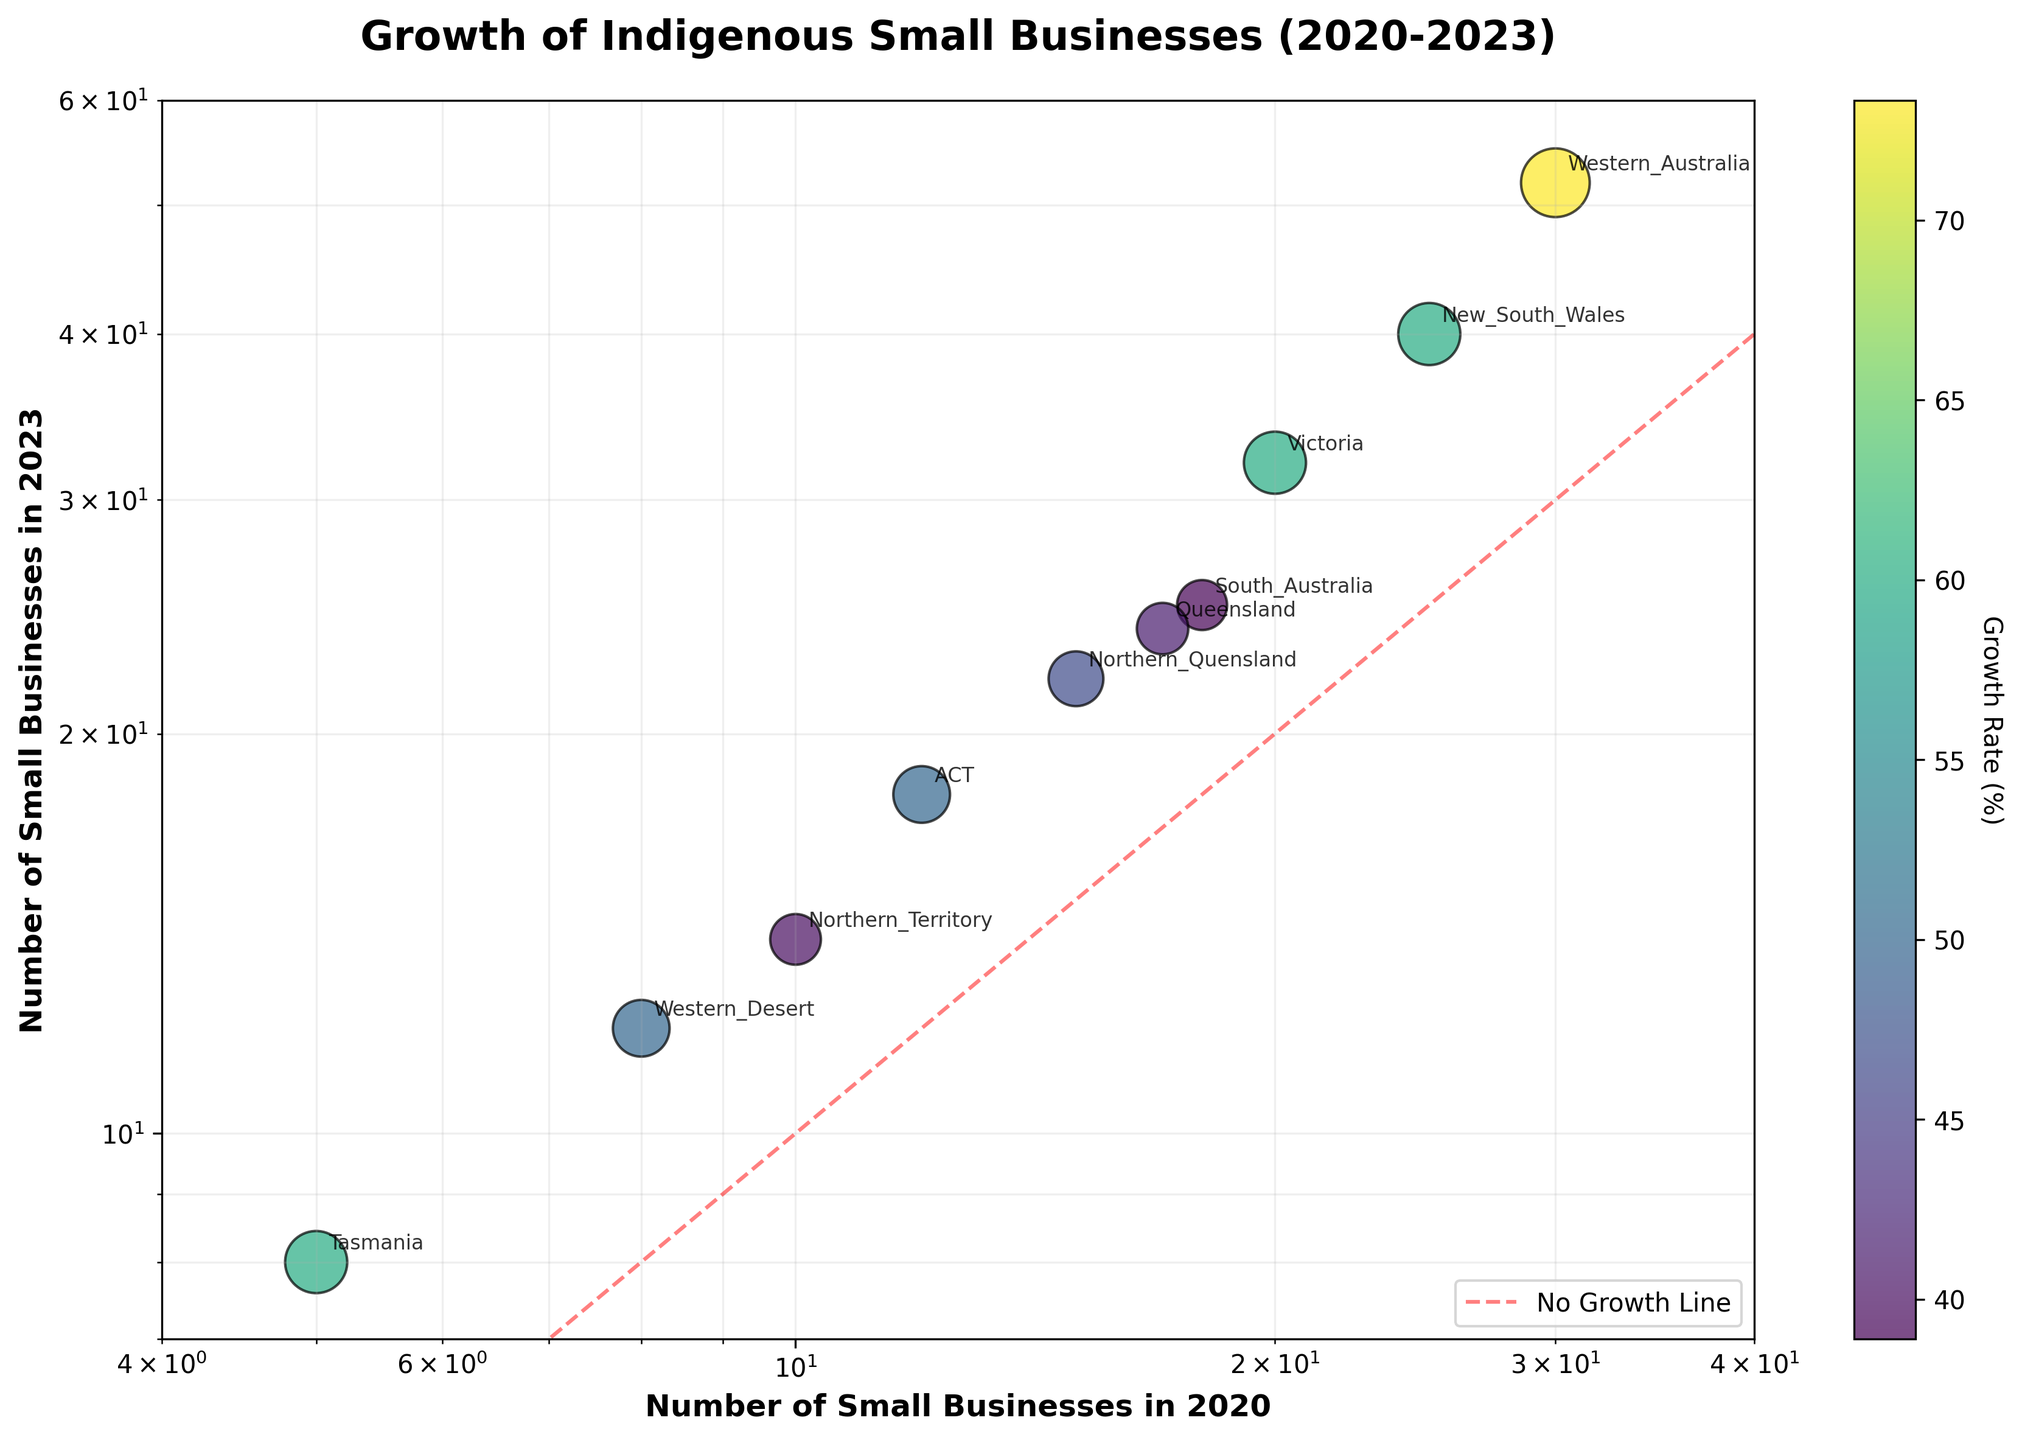What's the title of the scatter plot? The title is located at the top center of the plot area in a larger, bold font. It should describe the content and purpose of the scatter plot.
Answer: Growth of Indigenous Small Businesses (2020-2023) What are the x and y axes labeled as? The x-axis and y-axis labels are usually located at the bottom and left of the plot area, respectively, in a bold font. They indicate what each axis represents.
Answer: Number of Small Businesses in 2020 (x-axis) and Number of Small Businesses in 2023 (y-axis) Which region has the highest growth rate? Growth rate is indicated by the color intensity and the size of the scatter points. A more vibrant color and larger size denote a higher growth rate.
Answer: Western Australia How many regions have more than 20 small businesses in 2023? Look at the y-axis values and count the number of points that lie above the value of 20 on the log scale. Each of these points represents a region.
Answer: 5 Which region had around 12 small businesses in 2020 and fewer than 20 in 2023? Locate the point near the 12 mark on the x-axis and check the corresponding y-axis value to find the region name labeled nearby.
Answer: Western Desert Which region shows the least growth in small businesses? Look for the point closest to the dashed diagonal line that represents no growth. Refer to the label of that point.
Answer: Northern Territory What does the diagonal dashed line represent? The plot includes a red dashed line running diagonally from the bottom left to the top right. This line is usually used to indicate no growth, where values on the y-axis equal the values on the x-axis.
Answer: No Growth Line Which regions had their small business numbers double or more from 2020 to 2023? On a log-log plot, doubling can be identified if the point is above the line representing no growth, and y-value is at least twice the x-value.
Answer: Western Australia, Victoria, Tasmania 